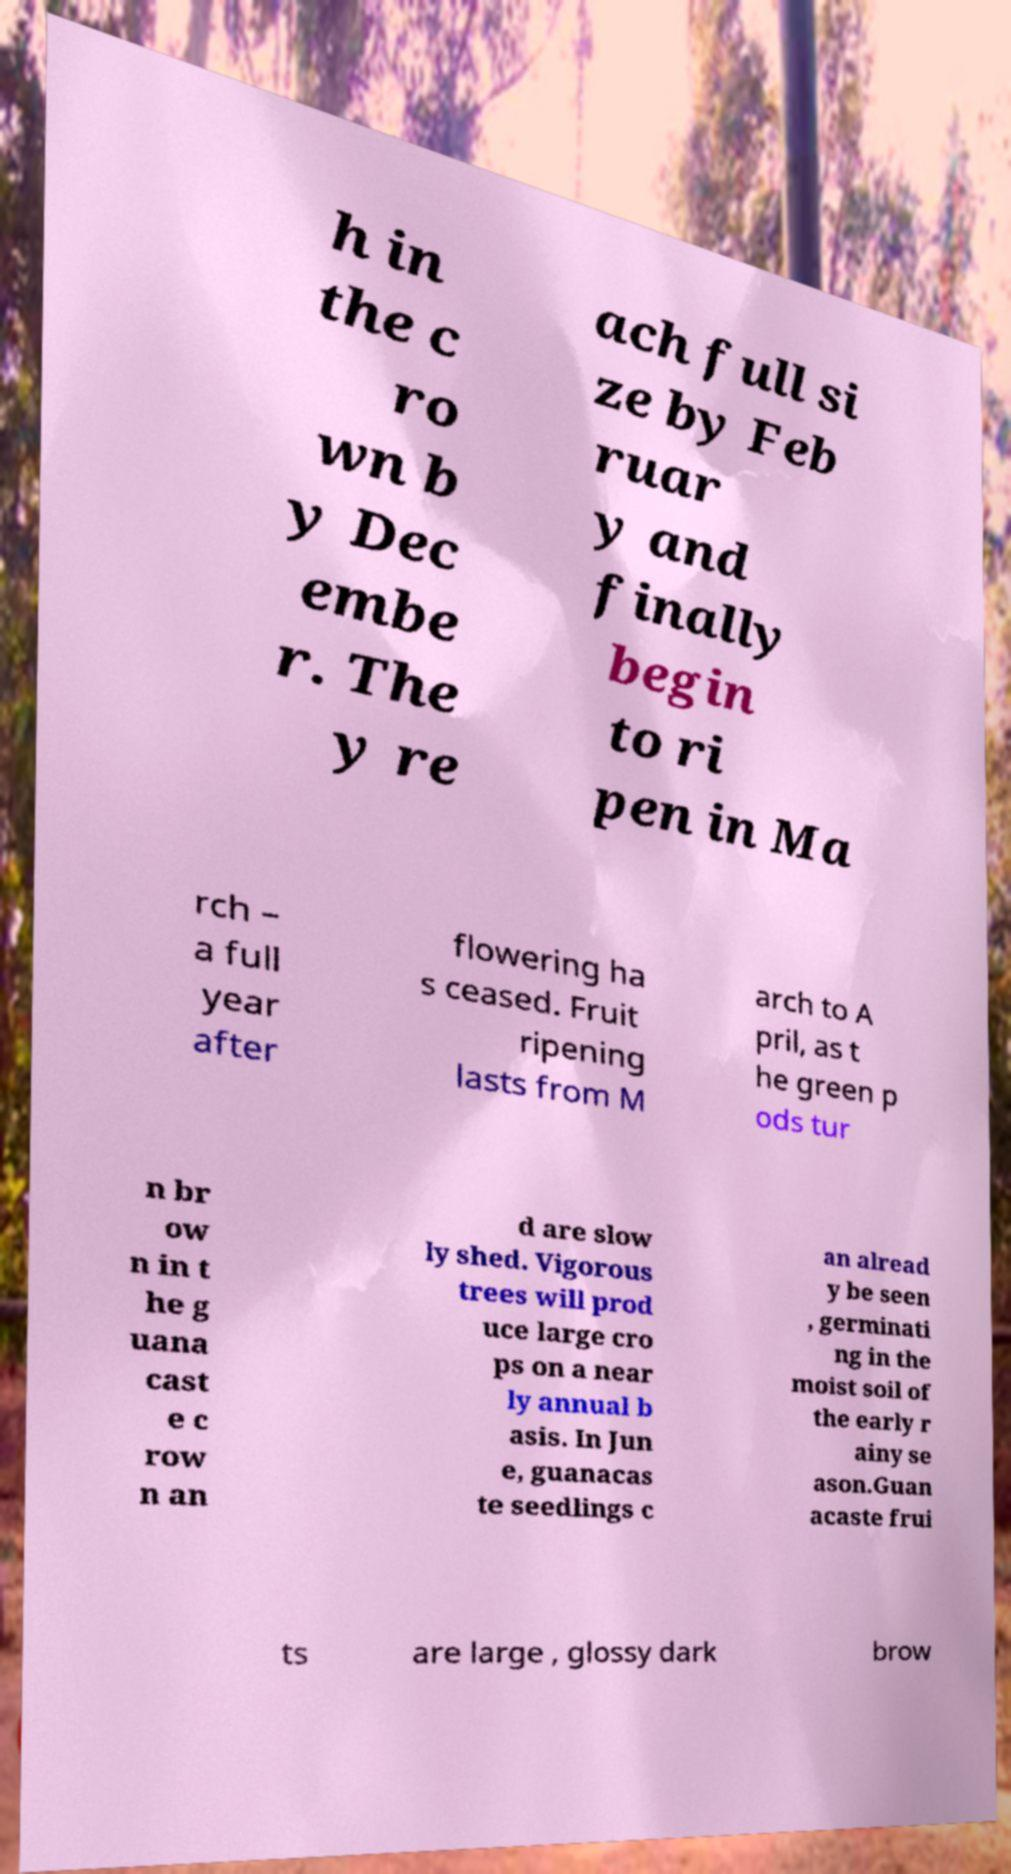Can you read and provide the text displayed in the image?This photo seems to have some interesting text. Can you extract and type it out for me? h in the c ro wn b y Dec embe r. The y re ach full si ze by Feb ruar y and finally begin to ri pen in Ma rch – a full year after flowering ha s ceased. Fruit ripening lasts from M arch to A pril, as t he green p ods tur n br ow n in t he g uana cast e c row n an d are slow ly shed. Vigorous trees will prod uce large cro ps on a near ly annual b asis. In Jun e, guanacas te seedlings c an alread y be seen , germinati ng in the moist soil of the early r ainy se ason.Guan acaste frui ts are large , glossy dark brow 